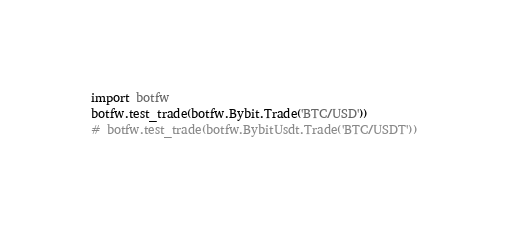<code> <loc_0><loc_0><loc_500><loc_500><_Python_>import botfw
botfw.test_trade(botfw.Bybit.Trade('BTC/USD'))
# botfw.test_trade(botfw.BybitUsdt.Trade('BTC/USDT'))
</code> 